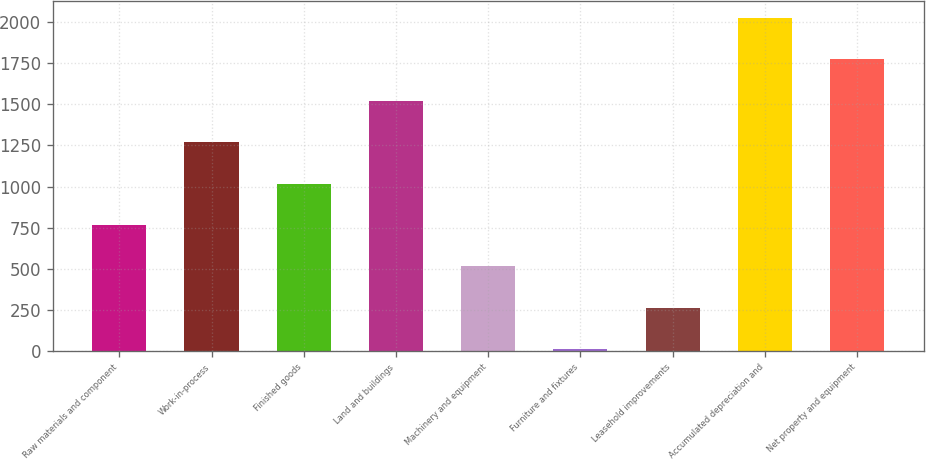Convert chart to OTSL. <chart><loc_0><loc_0><loc_500><loc_500><bar_chart><fcel>Raw materials and component<fcel>Work-in-process<fcel>Finished goods<fcel>Land and buildings<fcel>Machinery and equipment<fcel>Furniture and fixtures<fcel>Leasehold improvements<fcel>Accumulated depreciation and<fcel>Net property and equipment<nl><fcel>766.2<fcel>1271<fcel>1018.6<fcel>1523.4<fcel>513.8<fcel>9<fcel>261.4<fcel>2028.2<fcel>1775.8<nl></chart> 